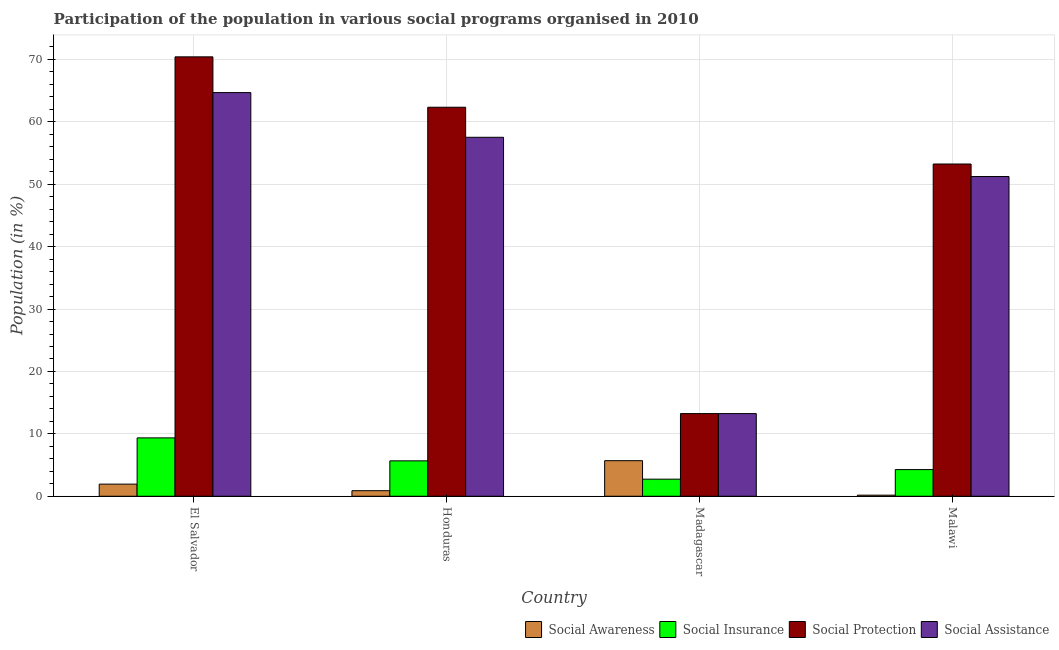Are the number of bars per tick equal to the number of legend labels?
Give a very brief answer. Yes. How many bars are there on the 3rd tick from the right?
Provide a succinct answer. 4. What is the label of the 3rd group of bars from the left?
Provide a succinct answer. Madagascar. What is the participation of population in social insurance programs in Malawi?
Give a very brief answer. 4.27. Across all countries, what is the maximum participation of population in social insurance programs?
Make the answer very short. 9.35. Across all countries, what is the minimum participation of population in social insurance programs?
Your response must be concise. 2.74. In which country was the participation of population in social insurance programs maximum?
Provide a succinct answer. El Salvador. In which country was the participation of population in social assistance programs minimum?
Your answer should be very brief. Madagascar. What is the total participation of population in social awareness programs in the graph?
Provide a succinct answer. 8.71. What is the difference between the participation of population in social protection programs in Honduras and that in Malawi?
Provide a succinct answer. 9.1. What is the difference between the participation of population in social protection programs in Honduras and the participation of population in social awareness programs in El Salvador?
Make the answer very short. 60.39. What is the average participation of population in social assistance programs per country?
Provide a succinct answer. 46.68. What is the difference between the participation of population in social awareness programs and participation of population in social assistance programs in Malawi?
Your answer should be compact. -51.06. What is the ratio of the participation of population in social awareness programs in Honduras to that in Madagascar?
Offer a very short reply. 0.16. Is the participation of population in social insurance programs in El Salvador less than that in Honduras?
Make the answer very short. No. What is the difference between the highest and the second highest participation of population in social insurance programs?
Provide a short and direct response. 3.68. What is the difference between the highest and the lowest participation of population in social insurance programs?
Offer a very short reply. 6.62. Is it the case that in every country, the sum of the participation of population in social awareness programs and participation of population in social insurance programs is greater than the sum of participation of population in social protection programs and participation of population in social assistance programs?
Ensure brevity in your answer.  Yes. What does the 3rd bar from the left in Madagascar represents?
Give a very brief answer. Social Protection. What does the 2nd bar from the right in El Salvador represents?
Keep it short and to the point. Social Protection. Is it the case that in every country, the sum of the participation of population in social awareness programs and participation of population in social insurance programs is greater than the participation of population in social protection programs?
Your answer should be very brief. No. How many bars are there?
Offer a terse response. 16. How many countries are there in the graph?
Provide a short and direct response. 4. What is the difference between two consecutive major ticks on the Y-axis?
Give a very brief answer. 10. Are the values on the major ticks of Y-axis written in scientific E-notation?
Provide a succinct answer. No. Does the graph contain any zero values?
Ensure brevity in your answer.  No. Does the graph contain grids?
Give a very brief answer. Yes. How are the legend labels stacked?
Provide a succinct answer. Horizontal. What is the title of the graph?
Your answer should be compact. Participation of the population in various social programs organised in 2010. Does "Forest" appear as one of the legend labels in the graph?
Offer a very short reply. No. What is the label or title of the X-axis?
Your response must be concise. Country. What is the Population (in %) of Social Awareness in El Salvador?
Provide a short and direct response. 1.95. What is the Population (in %) of Social Insurance in El Salvador?
Make the answer very short. 9.35. What is the Population (in %) of Social Protection in El Salvador?
Offer a terse response. 70.42. What is the Population (in %) of Social Assistance in El Salvador?
Your response must be concise. 64.69. What is the Population (in %) in Social Awareness in Honduras?
Your answer should be very brief. 0.89. What is the Population (in %) of Social Insurance in Honduras?
Provide a short and direct response. 5.67. What is the Population (in %) of Social Protection in Honduras?
Give a very brief answer. 62.34. What is the Population (in %) in Social Assistance in Honduras?
Your answer should be very brief. 57.53. What is the Population (in %) in Social Awareness in Madagascar?
Give a very brief answer. 5.7. What is the Population (in %) of Social Insurance in Madagascar?
Keep it short and to the point. 2.74. What is the Population (in %) in Social Protection in Madagascar?
Keep it short and to the point. 13.25. What is the Population (in %) of Social Assistance in Madagascar?
Provide a succinct answer. 13.25. What is the Population (in %) of Social Awareness in Malawi?
Keep it short and to the point. 0.18. What is the Population (in %) in Social Insurance in Malawi?
Ensure brevity in your answer.  4.27. What is the Population (in %) in Social Protection in Malawi?
Give a very brief answer. 53.24. What is the Population (in %) in Social Assistance in Malawi?
Ensure brevity in your answer.  51.24. Across all countries, what is the maximum Population (in %) in Social Awareness?
Make the answer very short. 5.7. Across all countries, what is the maximum Population (in %) of Social Insurance?
Offer a terse response. 9.35. Across all countries, what is the maximum Population (in %) in Social Protection?
Give a very brief answer. 70.42. Across all countries, what is the maximum Population (in %) of Social Assistance?
Make the answer very short. 64.69. Across all countries, what is the minimum Population (in %) of Social Awareness?
Provide a short and direct response. 0.18. Across all countries, what is the minimum Population (in %) of Social Insurance?
Keep it short and to the point. 2.74. Across all countries, what is the minimum Population (in %) of Social Protection?
Your response must be concise. 13.25. Across all countries, what is the minimum Population (in %) of Social Assistance?
Provide a succinct answer. 13.25. What is the total Population (in %) in Social Awareness in the graph?
Give a very brief answer. 8.71. What is the total Population (in %) in Social Insurance in the graph?
Make the answer very short. 22.04. What is the total Population (in %) of Social Protection in the graph?
Provide a short and direct response. 199.25. What is the total Population (in %) in Social Assistance in the graph?
Your response must be concise. 186.7. What is the difference between the Population (in %) in Social Awareness in El Salvador and that in Honduras?
Offer a very short reply. 1.06. What is the difference between the Population (in %) in Social Insurance in El Salvador and that in Honduras?
Provide a short and direct response. 3.68. What is the difference between the Population (in %) in Social Protection in El Salvador and that in Honduras?
Provide a short and direct response. 8.08. What is the difference between the Population (in %) in Social Assistance in El Salvador and that in Honduras?
Ensure brevity in your answer.  7.16. What is the difference between the Population (in %) in Social Awareness in El Salvador and that in Madagascar?
Provide a short and direct response. -3.75. What is the difference between the Population (in %) in Social Insurance in El Salvador and that in Madagascar?
Your answer should be very brief. 6.62. What is the difference between the Population (in %) in Social Protection in El Salvador and that in Madagascar?
Your answer should be compact. 57.17. What is the difference between the Population (in %) of Social Assistance in El Salvador and that in Madagascar?
Your response must be concise. 51.44. What is the difference between the Population (in %) in Social Awareness in El Salvador and that in Malawi?
Provide a short and direct response. 1.77. What is the difference between the Population (in %) of Social Insurance in El Salvador and that in Malawi?
Ensure brevity in your answer.  5.08. What is the difference between the Population (in %) in Social Protection in El Salvador and that in Malawi?
Offer a terse response. 17.17. What is the difference between the Population (in %) in Social Assistance in El Salvador and that in Malawi?
Ensure brevity in your answer.  13.45. What is the difference between the Population (in %) of Social Awareness in Honduras and that in Madagascar?
Offer a very short reply. -4.81. What is the difference between the Population (in %) in Social Insurance in Honduras and that in Madagascar?
Give a very brief answer. 2.93. What is the difference between the Population (in %) of Social Protection in Honduras and that in Madagascar?
Give a very brief answer. 49.09. What is the difference between the Population (in %) of Social Assistance in Honduras and that in Madagascar?
Your answer should be very brief. 44.28. What is the difference between the Population (in %) of Social Awareness in Honduras and that in Malawi?
Your answer should be very brief. 0.71. What is the difference between the Population (in %) of Social Insurance in Honduras and that in Malawi?
Offer a terse response. 1.4. What is the difference between the Population (in %) in Social Protection in Honduras and that in Malawi?
Provide a succinct answer. 9.1. What is the difference between the Population (in %) of Social Assistance in Honduras and that in Malawi?
Give a very brief answer. 6.29. What is the difference between the Population (in %) of Social Awareness in Madagascar and that in Malawi?
Your answer should be very brief. 5.52. What is the difference between the Population (in %) of Social Insurance in Madagascar and that in Malawi?
Offer a terse response. -1.53. What is the difference between the Population (in %) in Social Protection in Madagascar and that in Malawi?
Ensure brevity in your answer.  -39.99. What is the difference between the Population (in %) of Social Assistance in Madagascar and that in Malawi?
Your response must be concise. -37.99. What is the difference between the Population (in %) in Social Awareness in El Salvador and the Population (in %) in Social Insurance in Honduras?
Provide a succinct answer. -3.73. What is the difference between the Population (in %) in Social Awareness in El Salvador and the Population (in %) in Social Protection in Honduras?
Your answer should be very brief. -60.39. What is the difference between the Population (in %) of Social Awareness in El Salvador and the Population (in %) of Social Assistance in Honduras?
Make the answer very short. -55.58. What is the difference between the Population (in %) in Social Insurance in El Salvador and the Population (in %) in Social Protection in Honduras?
Your answer should be compact. -52.99. What is the difference between the Population (in %) of Social Insurance in El Salvador and the Population (in %) of Social Assistance in Honduras?
Your answer should be very brief. -48.17. What is the difference between the Population (in %) in Social Protection in El Salvador and the Population (in %) in Social Assistance in Honduras?
Offer a terse response. 12.89. What is the difference between the Population (in %) in Social Awareness in El Salvador and the Population (in %) in Social Insurance in Madagascar?
Keep it short and to the point. -0.79. What is the difference between the Population (in %) in Social Awareness in El Salvador and the Population (in %) in Social Protection in Madagascar?
Provide a succinct answer. -11.3. What is the difference between the Population (in %) in Social Awareness in El Salvador and the Population (in %) in Social Assistance in Madagascar?
Your answer should be very brief. -11.3. What is the difference between the Population (in %) of Social Insurance in El Salvador and the Population (in %) of Social Protection in Madagascar?
Your answer should be very brief. -3.89. What is the difference between the Population (in %) in Social Insurance in El Salvador and the Population (in %) in Social Assistance in Madagascar?
Your answer should be compact. -3.89. What is the difference between the Population (in %) in Social Protection in El Salvador and the Population (in %) in Social Assistance in Madagascar?
Your answer should be compact. 57.17. What is the difference between the Population (in %) of Social Awareness in El Salvador and the Population (in %) of Social Insurance in Malawi?
Keep it short and to the point. -2.33. What is the difference between the Population (in %) in Social Awareness in El Salvador and the Population (in %) in Social Protection in Malawi?
Offer a terse response. -51.3. What is the difference between the Population (in %) of Social Awareness in El Salvador and the Population (in %) of Social Assistance in Malawi?
Provide a short and direct response. -49.29. What is the difference between the Population (in %) in Social Insurance in El Salvador and the Population (in %) in Social Protection in Malawi?
Your response must be concise. -43.89. What is the difference between the Population (in %) of Social Insurance in El Salvador and the Population (in %) of Social Assistance in Malawi?
Make the answer very short. -41.88. What is the difference between the Population (in %) of Social Protection in El Salvador and the Population (in %) of Social Assistance in Malawi?
Provide a succinct answer. 19.18. What is the difference between the Population (in %) of Social Awareness in Honduras and the Population (in %) of Social Insurance in Madagascar?
Make the answer very short. -1.85. What is the difference between the Population (in %) in Social Awareness in Honduras and the Population (in %) in Social Protection in Madagascar?
Ensure brevity in your answer.  -12.36. What is the difference between the Population (in %) of Social Awareness in Honduras and the Population (in %) of Social Assistance in Madagascar?
Ensure brevity in your answer.  -12.36. What is the difference between the Population (in %) of Social Insurance in Honduras and the Population (in %) of Social Protection in Madagascar?
Keep it short and to the point. -7.57. What is the difference between the Population (in %) in Social Insurance in Honduras and the Population (in %) in Social Assistance in Madagascar?
Ensure brevity in your answer.  -7.57. What is the difference between the Population (in %) in Social Protection in Honduras and the Population (in %) in Social Assistance in Madagascar?
Offer a very short reply. 49.09. What is the difference between the Population (in %) of Social Awareness in Honduras and the Population (in %) of Social Insurance in Malawi?
Keep it short and to the point. -3.38. What is the difference between the Population (in %) of Social Awareness in Honduras and the Population (in %) of Social Protection in Malawi?
Offer a terse response. -52.35. What is the difference between the Population (in %) of Social Awareness in Honduras and the Population (in %) of Social Assistance in Malawi?
Ensure brevity in your answer.  -50.35. What is the difference between the Population (in %) in Social Insurance in Honduras and the Population (in %) in Social Protection in Malawi?
Provide a succinct answer. -47.57. What is the difference between the Population (in %) in Social Insurance in Honduras and the Population (in %) in Social Assistance in Malawi?
Offer a terse response. -45.57. What is the difference between the Population (in %) in Social Protection in Honduras and the Population (in %) in Social Assistance in Malawi?
Provide a short and direct response. 11.1. What is the difference between the Population (in %) of Social Awareness in Madagascar and the Population (in %) of Social Insurance in Malawi?
Your response must be concise. 1.43. What is the difference between the Population (in %) of Social Awareness in Madagascar and the Population (in %) of Social Protection in Malawi?
Make the answer very short. -47.54. What is the difference between the Population (in %) of Social Awareness in Madagascar and the Population (in %) of Social Assistance in Malawi?
Offer a very short reply. -45.54. What is the difference between the Population (in %) of Social Insurance in Madagascar and the Population (in %) of Social Protection in Malawi?
Your response must be concise. -50.5. What is the difference between the Population (in %) of Social Insurance in Madagascar and the Population (in %) of Social Assistance in Malawi?
Provide a succinct answer. -48.5. What is the difference between the Population (in %) of Social Protection in Madagascar and the Population (in %) of Social Assistance in Malawi?
Ensure brevity in your answer.  -37.99. What is the average Population (in %) of Social Awareness per country?
Provide a succinct answer. 2.18. What is the average Population (in %) in Social Insurance per country?
Provide a succinct answer. 5.51. What is the average Population (in %) in Social Protection per country?
Your answer should be compact. 49.81. What is the average Population (in %) of Social Assistance per country?
Provide a succinct answer. 46.68. What is the difference between the Population (in %) in Social Awareness and Population (in %) in Social Insurance in El Salvador?
Provide a succinct answer. -7.41. What is the difference between the Population (in %) in Social Awareness and Population (in %) in Social Protection in El Salvador?
Offer a terse response. -68.47. What is the difference between the Population (in %) of Social Awareness and Population (in %) of Social Assistance in El Salvador?
Provide a succinct answer. -62.74. What is the difference between the Population (in %) of Social Insurance and Population (in %) of Social Protection in El Salvador?
Keep it short and to the point. -61.06. What is the difference between the Population (in %) in Social Insurance and Population (in %) in Social Assistance in El Salvador?
Make the answer very short. -55.33. What is the difference between the Population (in %) in Social Protection and Population (in %) in Social Assistance in El Salvador?
Your answer should be very brief. 5.73. What is the difference between the Population (in %) of Social Awareness and Population (in %) of Social Insurance in Honduras?
Offer a very short reply. -4.78. What is the difference between the Population (in %) in Social Awareness and Population (in %) in Social Protection in Honduras?
Ensure brevity in your answer.  -61.45. What is the difference between the Population (in %) in Social Awareness and Population (in %) in Social Assistance in Honduras?
Your answer should be compact. -56.64. What is the difference between the Population (in %) of Social Insurance and Population (in %) of Social Protection in Honduras?
Provide a succinct answer. -56.67. What is the difference between the Population (in %) of Social Insurance and Population (in %) of Social Assistance in Honduras?
Keep it short and to the point. -51.85. What is the difference between the Population (in %) of Social Protection and Population (in %) of Social Assistance in Honduras?
Ensure brevity in your answer.  4.82. What is the difference between the Population (in %) in Social Awareness and Population (in %) in Social Insurance in Madagascar?
Ensure brevity in your answer.  2.96. What is the difference between the Population (in %) in Social Awareness and Population (in %) in Social Protection in Madagascar?
Ensure brevity in your answer.  -7.55. What is the difference between the Population (in %) in Social Awareness and Population (in %) in Social Assistance in Madagascar?
Provide a succinct answer. -7.55. What is the difference between the Population (in %) of Social Insurance and Population (in %) of Social Protection in Madagascar?
Your response must be concise. -10.51. What is the difference between the Population (in %) in Social Insurance and Population (in %) in Social Assistance in Madagascar?
Keep it short and to the point. -10.51. What is the difference between the Population (in %) in Social Protection and Population (in %) in Social Assistance in Madagascar?
Offer a terse response. 0. What is the difference between the Population (in %) of Social Awareness and Population (in %) of Social Insurance in Malawi?
Your answer should be compact. -4.1. What is the difference between the Population (in %) in Social Awareness and Population (in %) in Social Protection in Malawi?
Your response must be concise. -53.07. What is the difference between the Population (in %) of Social Awareness and Population (in %) of Social Assistance in Malawi?
Your answer should be very brief. -51.06. What is the difference between the Population (in %) of Social Insurance and Population (in %) of Social Protection in Malawi?
Keep it short and to the point. -48.97. What is the difference between the Population (in %) of Social Insurance and Population (in %) of Social Assistance in Malawi?
Your response must be concise. -46.96. What is the difference between the Population (in %) of Social Protection and Population (in %) of Social Assistance in Malawi?
Your answer should be very brief. 2. What is the ratio of the Population (in %) of Social Awareness in El Salvador to that in Honduras?
Give a very brief answer. 2.19. What is the ratio of the Population (in %) in Social Insurance in El Salvador to that in Honduras?
Ensure brevity in your answer.  1.65. What is the ratio of the Population (in %) in Social Protection in El Salvador to that in Honduras?
Your answer should be very brief. 1.13. What is the ratio of the Population (in %) of Social Assistance in El Salvador to that in Honduras?
Offer a very short reply. 1.12. What is the ratio of the Population (in %) in Social Awareness in El Salvador to that in Madagascar?
Your response must be concise. 0.34. What is the ratio of the Population (in %) of Social Insurance in El Salvador to that in Madagascar?
Your answer should be very brief. 3.42. What is the ratio of the Population (in %) of Social Protection in El Salvador to that in Madagascar?
Make the answer very short. 5.32. What is the ratio of the Population (in %) in Social Assistance in El Salvador to that in Madagascar?
Your answer should be compact. 4.88. What is the ratio of the Population (in %) in Social Awareness in El Salvador to that in Malawi?
Your response must be concise. 11.11. What is the ratio of the Population (in %) of Social Insurance in El Salvador to that in Malawi?
Provide a succinct answer. 2.19. What is the ratio of the Population (in %) in Social Protection in El Salvador to that in Malawi?
Keep it short and to the point. 1.32. What is the ratio of the Population (in %) in Social Assistance in El Salvador to that in Malawi?
Ensure brevity in your answer.  1.26. What is the ratio of the Population (in %) in Social Awareness in Honduras to that in Madagascar?
Ensure brevity in your answer.  0.16. What is the ratio of the Population (in %) of Social Insurance in Honduras to that in Madagascar?
Your answer should be very brief. 2.07. What is the ratio of the Population (in %) in Social Protection in Honduras to that in Madagascar?
Your answer should be very brief. 4.71. What is the ratio of the Population (in %) of Social Assistance in Honduras to that in Madagascar?
Your answer should be compact. 4.34. What is the ratio of the Population (in %) in Social Awareness in Honduras to that in Malawi?
Make the answer very short. 5.08. What is the ratio of the Population (in %) of Social Insurance in Honduras to that in Malawi?
Offer a very short reply. 1.33. What is the ratio of the Population (in %) of Social Protection in Honduras to that in Malawi?
Make the answer very short. 1.17. What is the ratio of the Population (in %) in Social Assistance in Honduras to that in Malawi?
Give a very brief answer. 1.12. What is the ratio of the Population (in %) of Social Awareness in Madagascar to that in Malawi?
Your response must be concise. 32.55. What is the ratio of the Population (in %) in Social Insurance in Madagascar to that in Malawi?
Ensure brevity in your answer.  0.64. What is the ratio of the Population (in %) of Social Protection in Madagascar to that in Malawi?
Keep it short and to the point. 0.25. What is the ratio of the Population (in %) of Social Assistance in Madagascar to that in Malawi?
Offer a terse response. 0.26. What is the difference between the highest and the second highest Population (in %) of Social Awareness?
Offer a very short reply. 3.75. What is the difference between the highest and the second highest Population (in %) of Social Insurance?
Your answer should be very brief. 3.68. What is the difference between the highest and the second highest Population (in %) in Social Protection?
Your answer should be compact. 8.08. What is the difference between the highest and the second highest Population (in %) in Social Assistance?
Make the answer very short. 7.16. What is the difference between the highest and the lowest Population (in %) in Social Awareness?
Offer a terse response. 5.52. What is the difference between the highest and the lowest Population (in %) in Social Insurance?
Make the answer very short. 6.62. What is the difference between the highest and the lowest Population (in %) in Social Protection?
Keep it short and to the point. 57.17. What is the difference between the highest and the lowest Population (in %) in Social Assistance?
Provide a short and direct response. 51.44. 